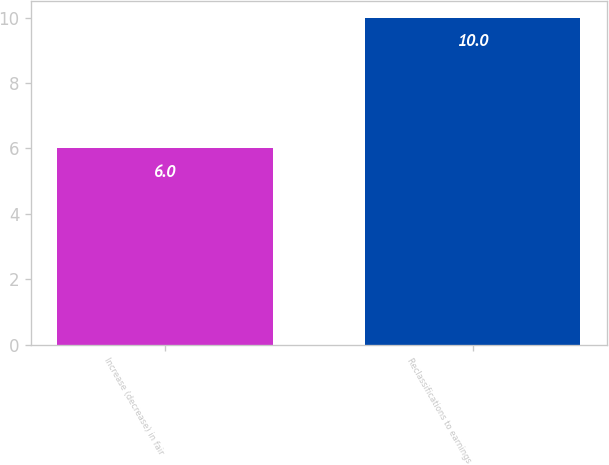<chart> <loc_0><loc_0><loc_500><loc_500><bar_chart><fcel>Increase (decrease) in fair<fcel>Reclassifications to earnings<nl><fcel>6<fcel>10<nl></chart> 